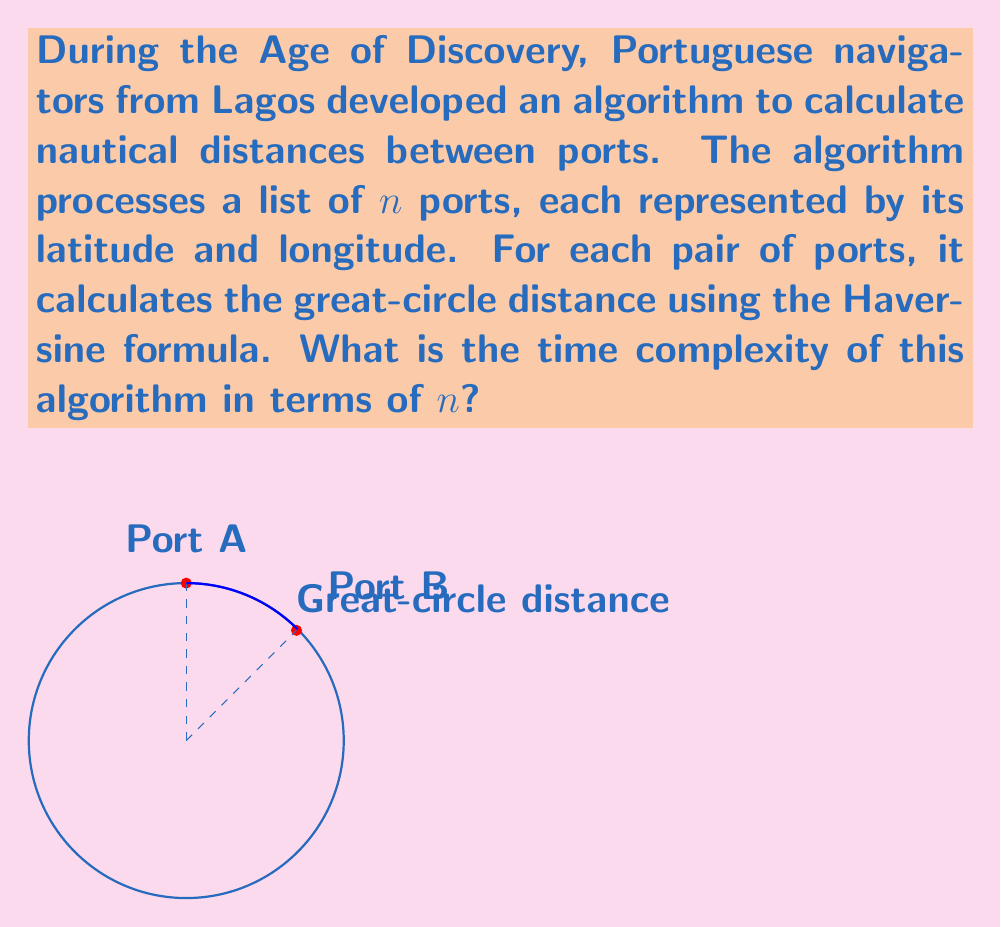Give your solution to this math problem. Let's analyze this algorithm step by step:

1) The algorithm needs to calculate the distance between every pair of ports.

2) For $n$ ports, there are $\binom{n}{2} = \frac{n(n-1)}{2}$ unique pairs.

3) For each pair, the algorithm performs the following steps:
   a) Retrieves latitude and longitude for both ports (constant time)
   b) Calculates the Haversine formula (constant time)

4) The Haversine formula itself involves constant-time operations (trigonometric functions, arithmetic operations).

5) Therefore, the time for each pair calculation is $O(1)$.

6) The total number of operations is proportional to the number of pairs:

   $$T(n) = O(\frac{n(n-1)}{2})$$

7) Simplifying this expression:
   
   $$O(\frac{n(n-1)}{2}) = O(\frac{n^2-n}{2}) = O(n^2)$$

8) The constant factor and lower-order terms are dropped in Big O notation.

Thus, the time complexity of this algorithm is quadratic in the number of ports.
Answer: $O(n^2)$ 